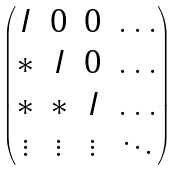Convert formula to latex. <formula><loc_0><loc_0><loc_500><loc_500>\begin{pmatrix} I & 0 & 0 & \dots \\ * & I & 0 & \dots \\ * & * & I & \dots \\ \vdots & \vdots & \vdots & \ddots \end{pmatrix}</formula> 